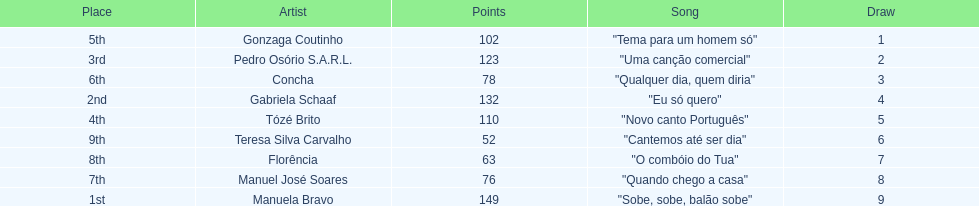Which artist came in last place? Teresa Silva Carvalho. 